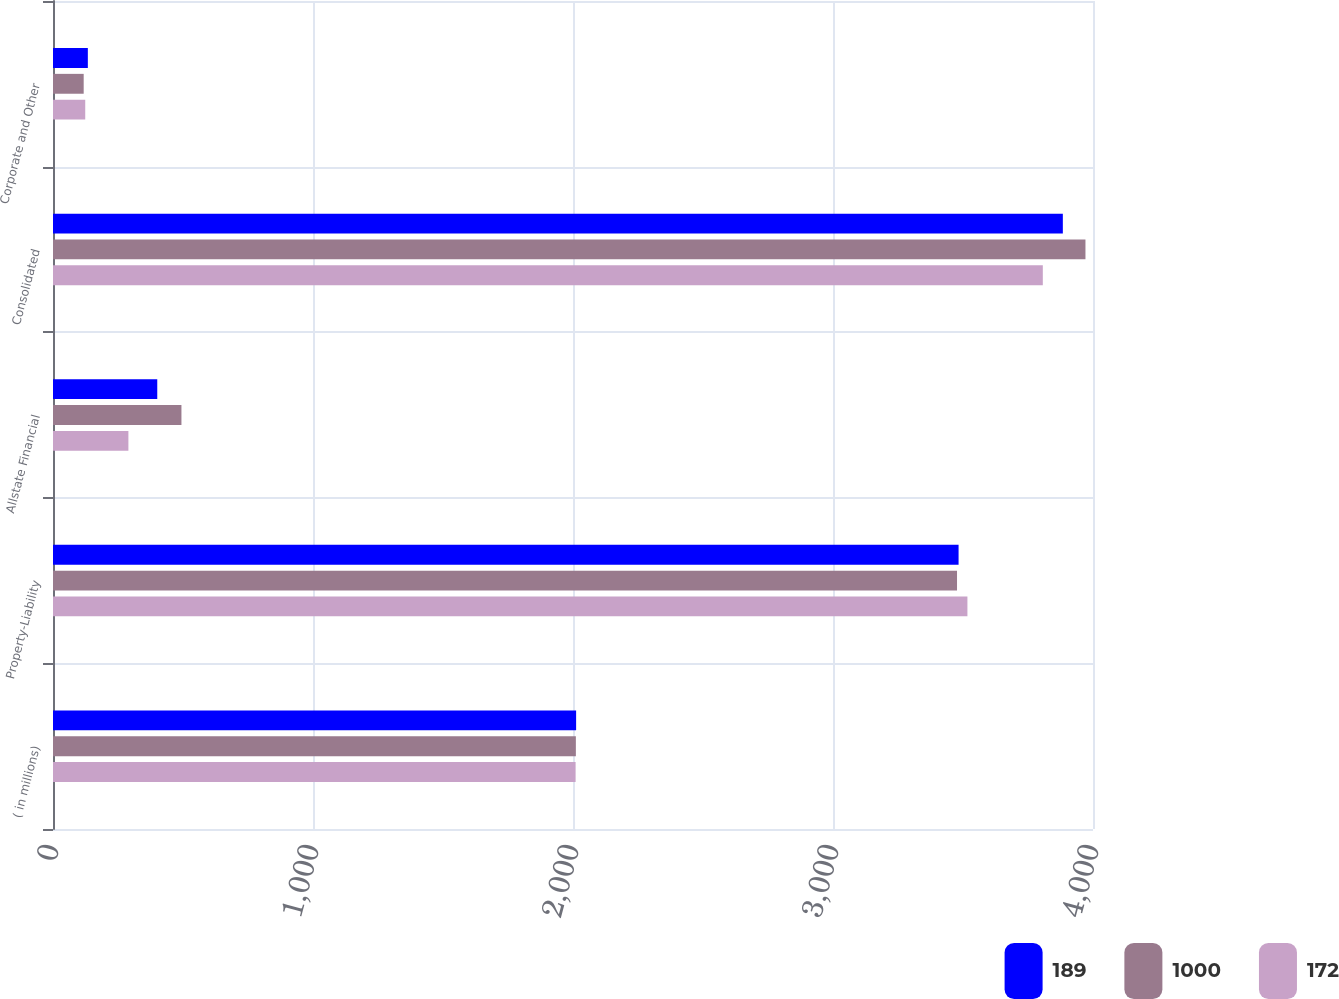Convert chart to OTSL. <chart><loc_0><loc_0><loc_500><loc_500><stacked_bar_chart><ecel><fcel>( in millions)<fcel>Property-Liability<fcel>Allstate Financial<fcel>Consolidated<fcel>Corporate and Other<nl><fcel>189<fcel>2012<fcel>3483<fcel>401<fcel>3884<fcel>134<nl><fcel>1000<fcel>2011<fcel>3477<fcel>494<fcel>3971<fcel>118<nl><fcel>172<fcel>2010<fcel>3517<fcel>290<fcel>3807<fcel>124<nl></chart> 